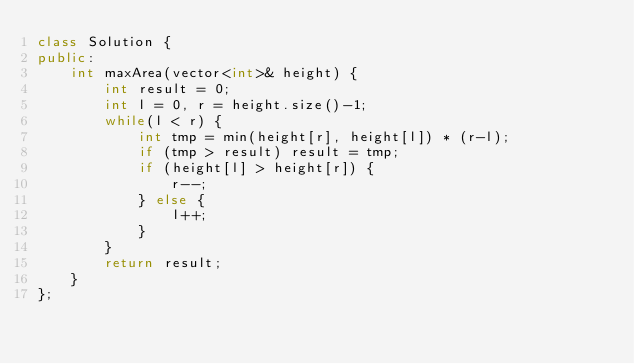Convert code to text. <code><loc_0><loc_0><loc_500><loc_500><_C++_>class Solution {
public:
    int maxArea(vector<int>& height) {
        int result = 0;
        int l = 0, r = height.size()-1;
        while(l < r) {
            int tmp = min(height[r], height[l]) * (r-l);
            if (tmp > result) result = tmp;
            if (height[l] > height[r]) {
                r--;
            } else {
                l++;
            }
        }
        return result;
    }
};</code> 